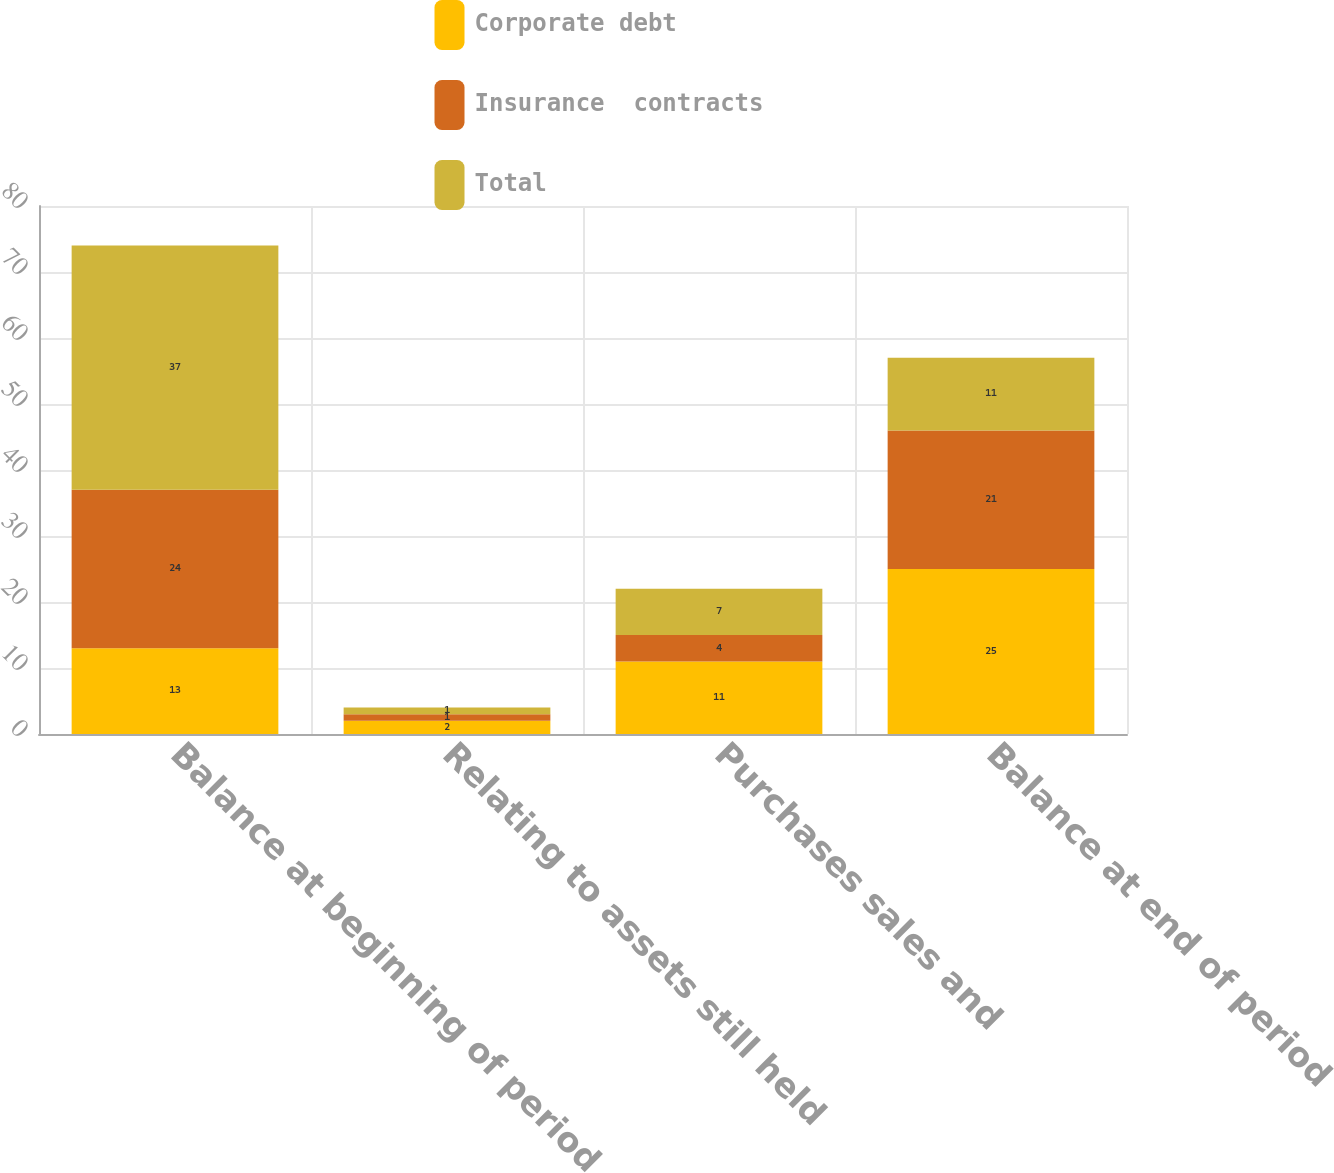Convert chart to OTSL. <chart><loc_0><loc_0><loc_500><loc_500><stacked_bar_chart><ecel><fcel>Balance at beginning of period<fcel>Relating to assets still held<fcel>Purchases sales and<fcel>Balance at end of period<nl><fcel>Corporate debt<fcel>13<fcel>2<fcel>11<fcel>25<nl><fcel>Insurance  contracts<fcel>24<fcel>1<fcel>4<fcel>21<nl><fcel>Total<fcel>37<fcel>1<fcel>7<fcel>11<nl></chart> 